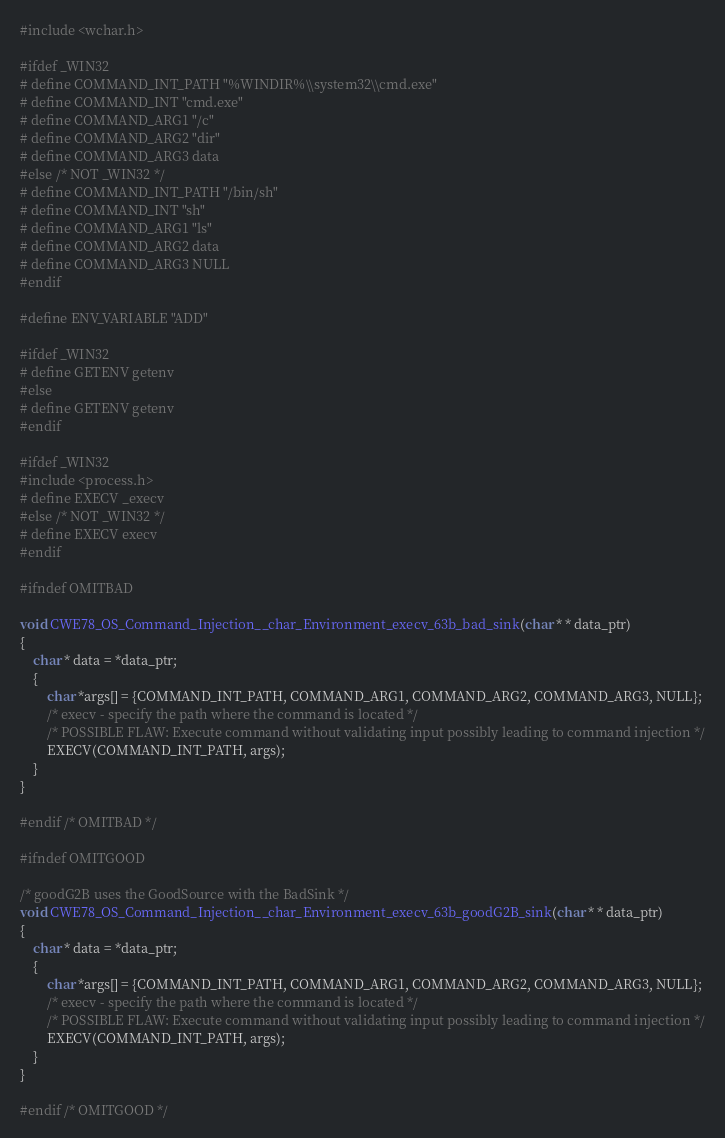<code> <loc_0><loc_0><loc_500><loc_500><_C_>
#include <wchar.h>

#ifdef _WIN32
# define COMMAND_INT_PATH "%WINDIR%\\system32\\cmd.exe"
# define COMMAND_INT "cmd.exe"
# define COMMAND_ARG1 "/c"
# define COMMAND_ARG2 "dir"
# define COMMAND_ARG3 data
#else /* NOT _WIN32 */
# define COMMAND_INT_PATH "/bin/sh"
# define COMMAND_INT "sh"
# define COMMAND_ARG1 "ls"
# define COMMAND_ARG2 data
# define COMMAND_ARG3 NULL
#endif

#define ENV_VARIABLE "ADD"

#ifdef _WIN32
# define GETENV getenv
#else
# define GETENV getenv
#endif

#ifdef _WIN32
#include <process.h>
# define EXECV _execv
#else /* NOT _WIN32 */
# define EXECV execv
#endif

#ifndef OMITBAD

void CWE78_OS_Command_Injection__char_Environment_execv_63b_bad_sink(char * * data_ptr)
{
    char * data = *data_ptr;
    {
        char *args[] = {COMMAND_INT_PATH, COMMAND_ARG1, COMMAND_ARG2, COMMAND_ARG3, NULL};
        /* execv - specify the path where the command is located */
        /* POSSIBLE FLAW: Execute command without validating input possibly leading to command injection */
        EXECV(COMMAND_INT_PATH, args);
    }
}

#endif /* OMITBAD */

#ifndef OMITGOOD

/* goodG2B uses the GoodSource with the BadSink */
void CWE78_OS_Command_Injection__char_Environment_execv_63b_goodG2B_sink(char * * data_ptr)
{
    char * data = *data_ptr;
    {
        char *args[] = {COMMAND_INT_PATH, COMMAND_ARG1, COMMAND_ARG2, COMMAND_ARG3, NULL};
        /* execv - specify the path where the command is located */
        /* POSSIBLE FLAW: Execute command without validating input possibly leading to command injection */
        EXECV(COMMAND_INT_PATH, args);
    }
}

#endif /* OMITGOOD */
</code> 